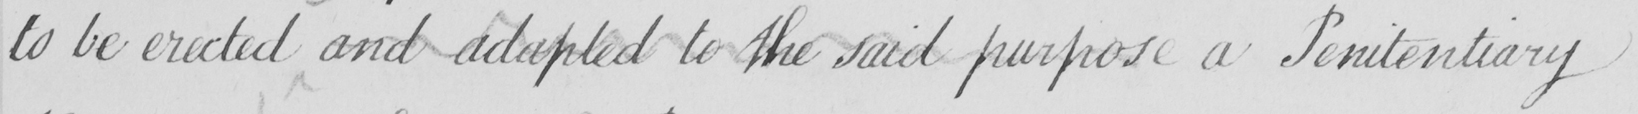What text is written in this handwritten line? to be erected and adapted to the said purpose a Penitentiary 